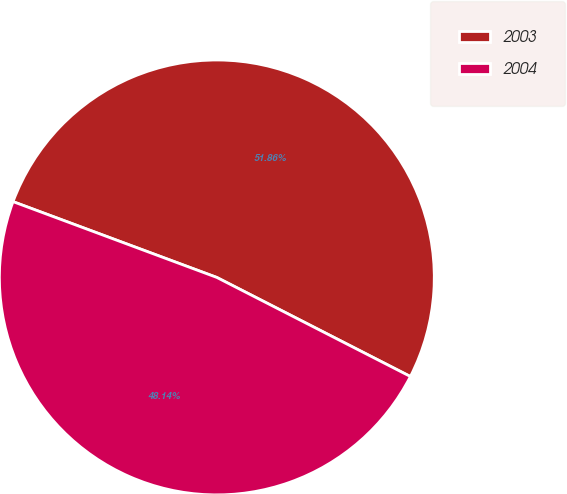Convert chart to OTSL. <chart><loc_0><loc_0><loc_500><loc_500><pie_chart><fcel>2003<fcel>2004<nl><fcel>51.86%<fcel>48.14%<nl></chart> 